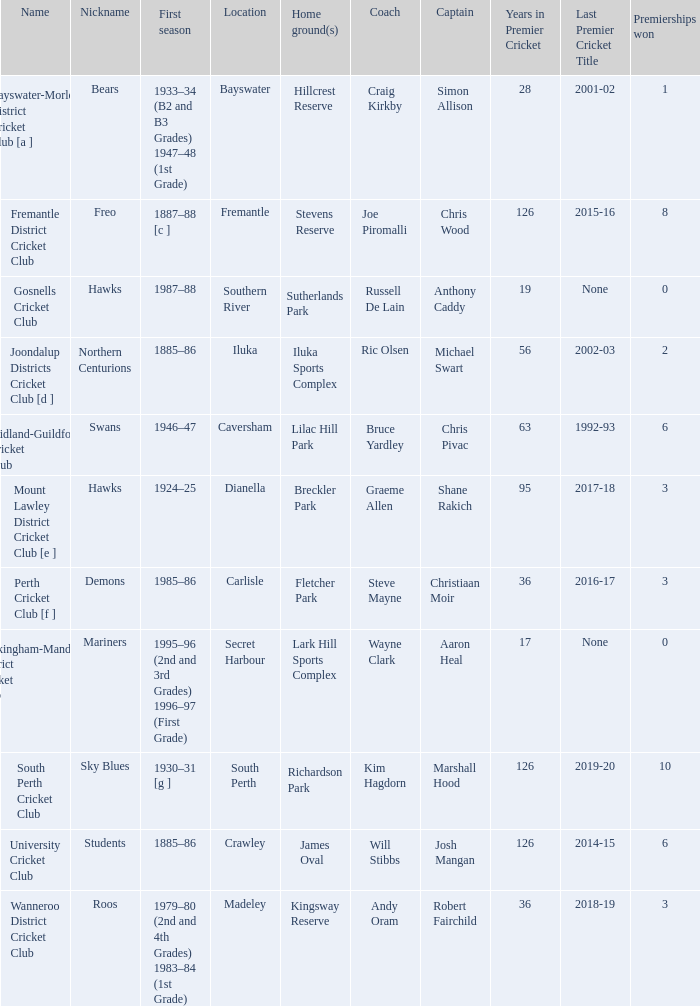Write the full table. {'header': ['Name', 'Nickname', 'First season', 'Location', 'Home ground(s)', 'Coach', 'Captain', 'Years in Premier Cricket', 'Last Premier Cricket Title', 'Premierships won'], 'rows': [['Bayswater-Morley District Cricket Club [a ]', 'Bears', '1933–34 (B2 and B3 Grades) 1947–48 (1st Grade)', 'Bayswater', 'Hillcrest Reserve', 'Craig Kirkby', 'Simon Allison', '28', '2001-02', '1'], ['Fremantle District Cricket Club', 'Freo', '1887–88 [c ]', 'Fremantle', 'Stevens Reserve', 'Joe Piromalli', 'Chris Wood', '126', '2015-16', '8'], ['Gosnells Cricket Club', 'Hawks', '1987–88', 'Southern River', 'Sutherlands Park', 'Russell De Lain', 'Anthony Caddy', '19', 'None', '0'], ['Joondalup Districts Cricket Club [d ]', 'Northern Centurions', '1885–86', 'Iluka', 'Iluka Sports Complex', 'Ric Olsen', 'Michael Swart', '56', '2002-03', '2'], ['Midland-Guildford Cricket Club', 'Swans', '1946–47', 'Caversham', 'Lilac Hill Park', 'Bruce Yardley', 'Chris Pivac', '63', '1992-93', '6'], ['Mount Lawley District Cricket Club [e ]', 'Hawks', '1924–25', 'Dianella', 'Breckler Park', 'Graeme Allen', 'Shane Rakich', '95', '2017-18', '3'], ['Perth Cricket Club [f ]', 'Demons', '1985–86', 'Carlisle', 'Fletcher Park', 'Steve Mayne', 'Christiaan Moir', '36', '2016-17', '3'], ['Rockingham-Mandurah District Cricket Club', 'Mariners', '1995–96 (2nd and 3rd Grades) 1996–97 (First Grade)', 'Secret Harbour', 'Lark Hill Sports Complex', 'Wayne Clark', 'Aaron Heal', '17', 'None', '0'], ['South Perth Cricket Club', 'Sky Blues', '1930–31 [g ]', 'South Perth', 'Richardson Park', 'Kim Hagdorn', 'Marshall Hood', '126', '2019-20', '10'], ['University Cricket Club', 'Students', '1885–86', 'Crawley', 'James Oval', 'Will Stibbs', 'Josh Mangan', '126', '2014-15', '6'], ['Wanneroo District Cricket Club', 'Roos', '1979–80 (2nd and 4th Grades) 1983–84 (1st Grade)', 'Madeley', 'Kingsway Reserve', 'Andy Oram', 'Robert Fairchild', '36', '2018-19', '3']]} For location Caversham, what is the name of the captain? Chris Pivac. 